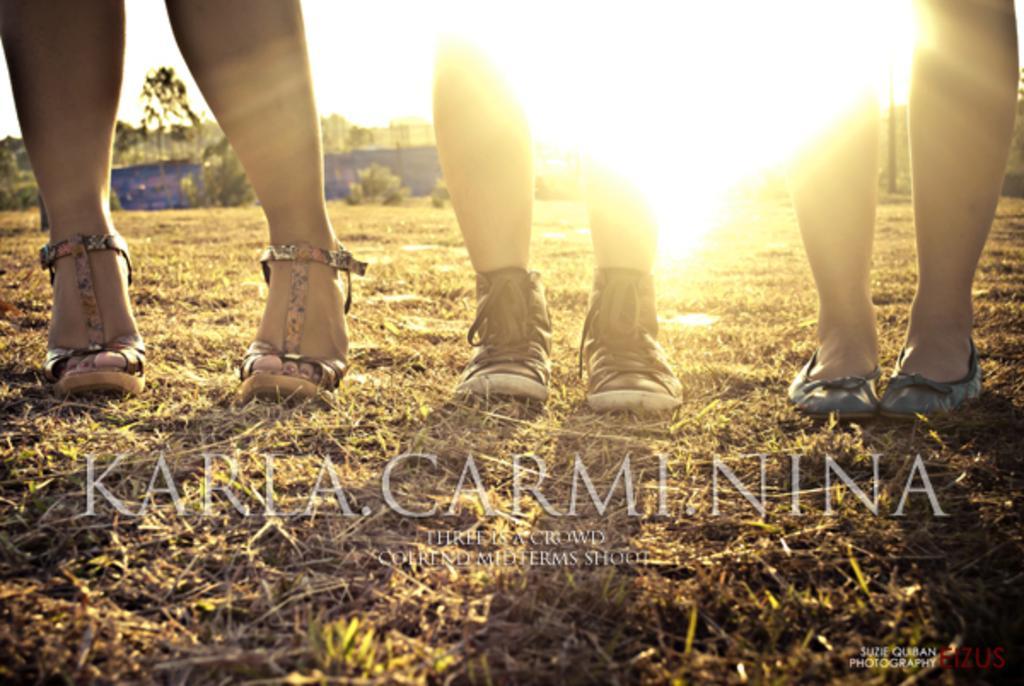Describe this image in one or two sentences. In this image in the center there are some people who are standing, at the bottom there is grass. In the background there are some trees, and at the bottom of the image there is some text. 